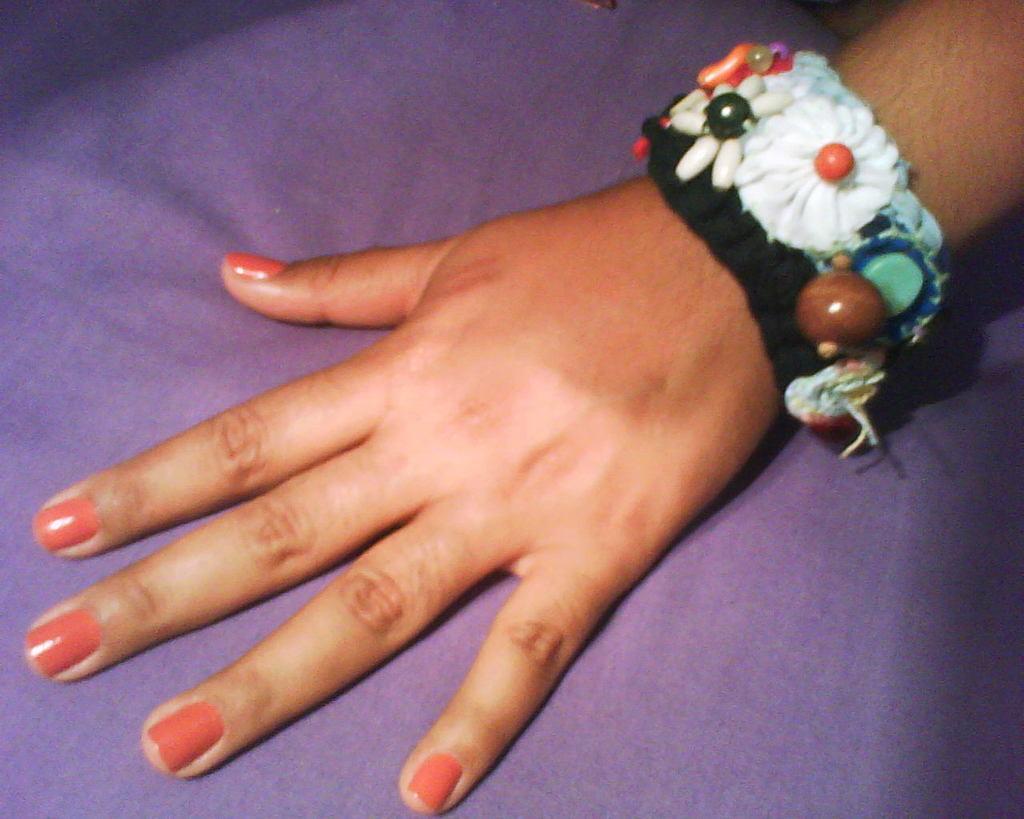Please provide a concise description of this image. This is a human hand, this is a band, this is purple color. 